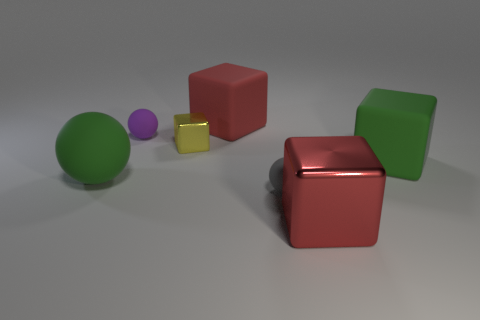Subtract 1 cubes. How many cubes are left? 3 Add 1 big cyan metallic things. How many objects exist? 8 Subtract all balls. How many objects are left? 4 Add 2 green matte objects. How many green matte objects are left? 4 Add 3 green cylinders. How many green cylinders exist? 3 Subtract 0 brown blocks. How many objects are left? 7 Subtract all tiny purple rubber balls. Subtract all big cubes. How many objects are left? 3 